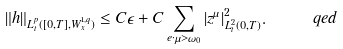Convert formula to latex. <formula><loc_0><loc_0><loc_500><loc_500>\| h \| _ { L ^ { p } _ { t } ( [ 0 , T ] , W ^ { 1 , q } _ { x } ) } \leq C \epsilon + C \sum _ { e \cdot \mu > \omega _ { 0 } } | z ^ { \mu } | ^ { 2 } _ { L ^ { 2 } _ { t } ( 0 , T ) } . \quad \ q e d</formula> 